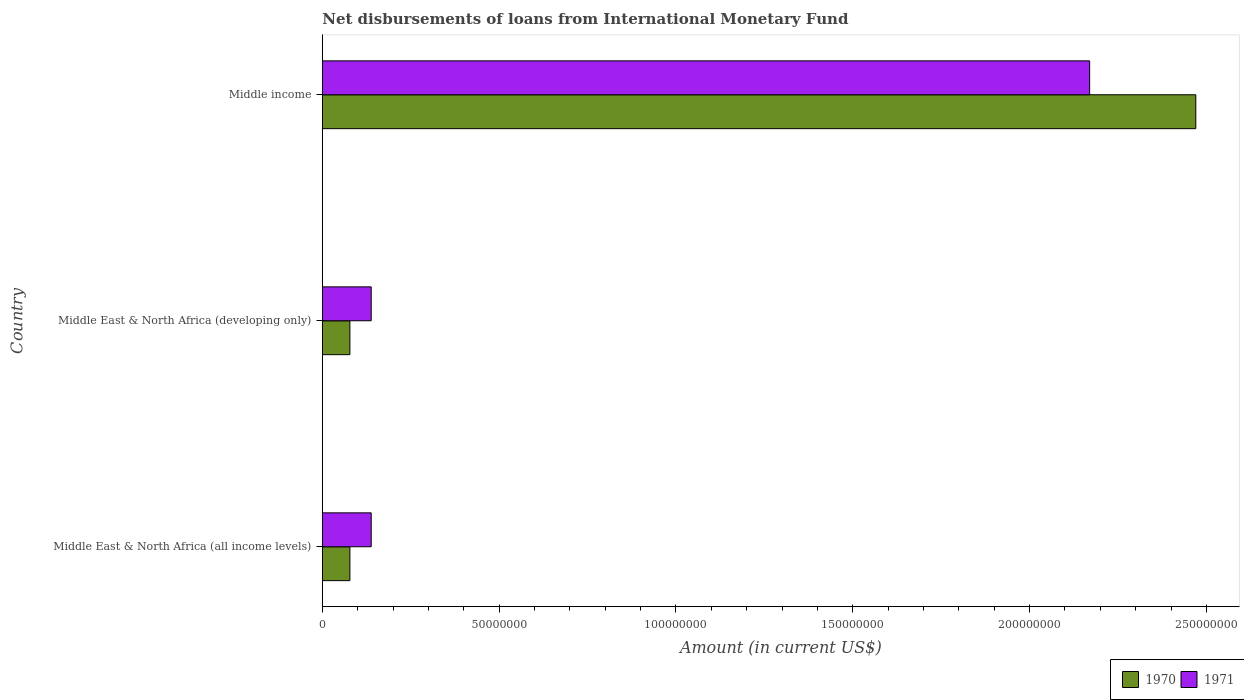How many groups of bars are there?
Keep it short and to the point. 3. Are the number of bars per tick equal to the number of legend labels?
Provide a succinct answer. Yes. What is the label of the 2nd group of bars from the top?
Keep it short and to the point. Middle East & North Africa (developing only). What is the amount of loans disbursed in 1971 in Middle East & North Africa (all income levels)?
Give a very brief answer. 1.38e+07. Across all countries, what is the maximum amount of loans disbursed in 1971?
Offer a terse response. 2.17e+08. Across all countries, what is the minimum amount of loans disbursed in 1971?
Keep it short and to the point. 1.38e+07. In which country was the amount of loans disbursed in 1971 maximum?
Your answer should be very brief. Middle income. In which country was the amount of loans disbursed in 1971 minimum?
Ensure brevity in your answer.  Middle East & North Africa (all income levels). What is the total amount of loans disbursed in 1971 in the graph?
Your response must be concise. 2.45e+08. What is the difference between the amount of loans disbursed in 1970 in Middle East & North Africa (all income levels) and that in Middle East & North Africa (developing only)?
Provide a short and direct response. 0. What is the difference between the amount of loans disbursed in 1970 in Middle East & North Africa (all income levels) and the amount of loans disbursed in 1971 in Middle East & North Africa (developing only)?
Offer a very short reply. -6.03e+06. What is the average amount of loans disbursed in 1970 per country?
Provide a short and direct response. 8.75e+07. What is the difference between the amount of loans disbursed in 1971 and amount of loans disbursed in 1970 in Middle income?
Ensure brevity in your answer.  -3.00e+07. In how many countries, is the amount of loans disbursed in 1970 greater than 180000000 US$?
Keep it short and to the point. 1. What is the ratio of the amount of loans disbursed in 1970 in Middle East & North Africa (developing only) to that in Middle income?
Your answer should be compact. 0.03. What is the difference between the highest and the second highest amount of loans disbursed in 1970?
Ensure brevity in your answer.  2.39e+08. What is the difference between the highest and the lowest amount of loans disbursed in 1971?
Keep it short and to the point. 2.03e+08. In how many countries, is the amount of loans disbursed in 1971 greater than the average amount of loans disbursed in 1971 taken over all countries?
Your answer should be very brief. 1. Is the sum of the amount of loans disbursed in 1971 in Middle East & North Africa (all income levels) and Middle East & North Africa (developing only) greater than the maximum amount of loans disbursed in 1970 across all countries?
Offer a very short reply. No. Are all the bars in the graph horizontal?
Ensure brevity in your answer.  Yes. How many countries are there in the graph?
Keep it short and to the point. 3. Are the values on the major ticks of X-axis written in scientific E-notation?
Provide a succinct answer. No. Does the graph contain grids?
Your response must be concise. No. How many legend labels are there?
Your response must be concise. 2. How are the legend labels stacked?
Your answer should be compact. Horizontal. What is the title of the graph?
Give a very brief answer. Net disbursements of loans from International Monetary Fund. Does "1992" appear as one of the legend labels in the graph?
Provide a succinct answer. No. What is the label or title of the Y-axis?
Offer a terse response. Country. What is the Amount (in current US$) of 1970 in Middle East & North Africa (all income levels)?
Your answer should be compact. 7.79e+06. What is the Amount (in current US$) in 1971 in Middle East & North Africa (all income levels)?
Make the answer very short. 1.38e+07. What is the Amount (in current US$) in 1970 in Middle East & North Africa (developing only)?
Keep it short and to the point. 7.79e+06. What is the Amount (in current US$) in 1971 in Middle East & North Africa (developing only)?
Your answer should be very brief. 1.38e+07. What is the Amount (in current US$) in 1970 in Middle income?
Ensure brevity in your answer.  2.47e+08. What is the Amount (in current US$) of 1971 in Middle income?
Ensure brevity in your answer.  2.17e+08. Across all countries, what is the maximum Amount (in current US$) in 1970?
Offer a very short reply. 2.47e+08. Across all countries, what is the maximum Amount (in current US$) in 1971?
Ensure brevity in your answer.  2.17e+08. Across all countries, what is the minimum Amount (in current US$) of 1970?
Keep it short and to the point. 7.79e+06. Across all countries, what is the minimum Amount (in current US$) in 1971?
Make the answer very short. 1.38e+07. What is the total Amount (in current US$) in 1970 in the graph?
Your answer should be very brief. 2.63e+08. What is the total Amount (in current US$) in 1971 in the graph?
Your response must be concise. 2.45e+08. What is the difference between the Amount (in current US$) in 1970 in Middle East & North Africa (all income levels) and that in Middle East & North Africa (developing only)?
Provide a succinct answer. 0. What is the difference between the Amount (in current US$) in 1971 in Middle East & North Africa (all income levels) and that in Middle East & North Africa (developing only)?
Provide a short and direct response. 0. What is the difference between the Amount (in current US$) of 1970 in Middle East & North Africa (all income levels) and that in Middle income?
Your answer should be compact. -2.39e+08. What is the difference between the Amount (in current US$) in 1971 in Middle East & North Africa (all income levels) and that in Middle income?
Ensure brevity in your answer.  -2.03e+08. What is the difference between the Amount (in current US$) of 1970 in Middle East & North Africa (developing only) and that in Middle income?
Make the answer very short. -2.39e+08. What is the difference between the Amount (in current US$) of 1971 in Middle East & North Africa (developing only) and that in Middle income?
Offer a very short reply. -2.03e+08. What is the difference between the Amount (in current US$) in 1970 in Middle East & North Africa (all income levels) and the Amount (in current US$) in 1971 in Middle East & North Africa (developing only)?
Offer a terse response. -6.03e+06. What is the difference between the Amount (in current US$) in 1970 in Middle East & North Africa (all income levels) and the Amount (in current US$) in 1971 in Middle income?
Ensure brevity in your answer.  -2.09e+08. What is the difference between the Amount (in current US$) in 1970 in Middle East & North Africa (developing only) and the Amount (in current US$) in 1971 in Middle income?
Make the answer very short. -2.09e+08. What is the average Amount (in current US$) of 1970 per country?
Ensure brevity in your answer.  8.75e+07. What is the average Amount (in current US$) of 1971 per country?
Your response must be concise. 8.15e+07. What is the difference between the Amount (in current US$) of 1970 and Amount (in current US$) of 1971 in Middle East & North Africa (all income levels)?
Make the answer very short. -6.03e+06. What is the difference between the Amount (in current US$) of 1970 and Amount (in current US$) of 1971 in Middle East & North Africa (developing only)?
Make the answer very short. -6.03e+06. What is the difference between the Amount (in current US$) of 1970 and Amount (in current US$) of 1971 in Middle income?
Ensure brevity in your answer.  3.00e+07. What is the ratio of the Amount (in current US$) in 1970 in Middle East & North Africa (all income levels) to that in Middle income?
Offer a very short reply. 0.03. What is the ratio of the Amount (in current US$) in 1971 in Middle East & North Africa (all income levels) to that in Middle income?
Keep it short and to the point. 0.06. What is the ratio of the Amount (in current US$) in 1970 in Middle East & North Africa (developing only) to that in Middle income?
Provide a short and direct response. 0.03. What is the ratio of the Amount (in current US$) of 1971 in Middle East & North Africa (developing only) to that in Middle income?
Offer a very short reply. 0.06. What is the difference between the highest and the second highest Amount (in current US$) of 1970?
Offer a very short reply. 2.39e+08. What is the difference between the highest and the second highest Amount (in current US$) in 1971?
Keep it short and to the point. 2.03e+08. What is the difference between the highest and the lowest Amount (in current US$) of 1970?
Your response must be concise. 2.39e+08. What is the difference between the highest and the lowest Amount (in current US$) in 1971?
Your answer should be very brief. 2.03e+08. 